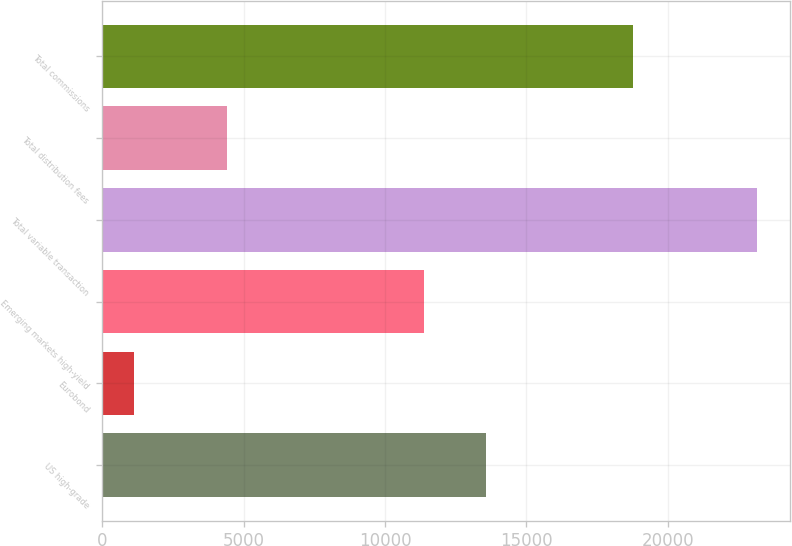<chart> <loc_0><loc_0><loc_500><loc_500><bar_chart><fcel>US high-grade<fcel>Eurobond<fcel>Emerging markets high-yield<fcel>Total variable transaction<fcel>Total distribution fees<fcel>Total commissions<nl><fcel>13577.7<fcel>1129<fcel>11374<fcel>23166<fcel>4411<fcel>18755<nl></chart> 